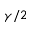<formula> <loc_0><loc_0><loc_500><loc_500>\gamma / 2</formula> 